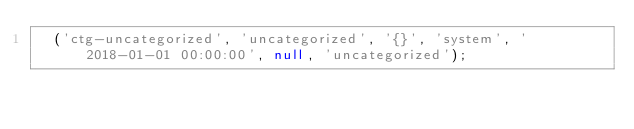<code> <loc_0><loc_0><loc_500><loc_500><_SQL_>	('ctg-uncategorized', 'uncategorized', '{}', 'system', '2018-01-01 00:00:00', null, 'uncategorized');
</code> 